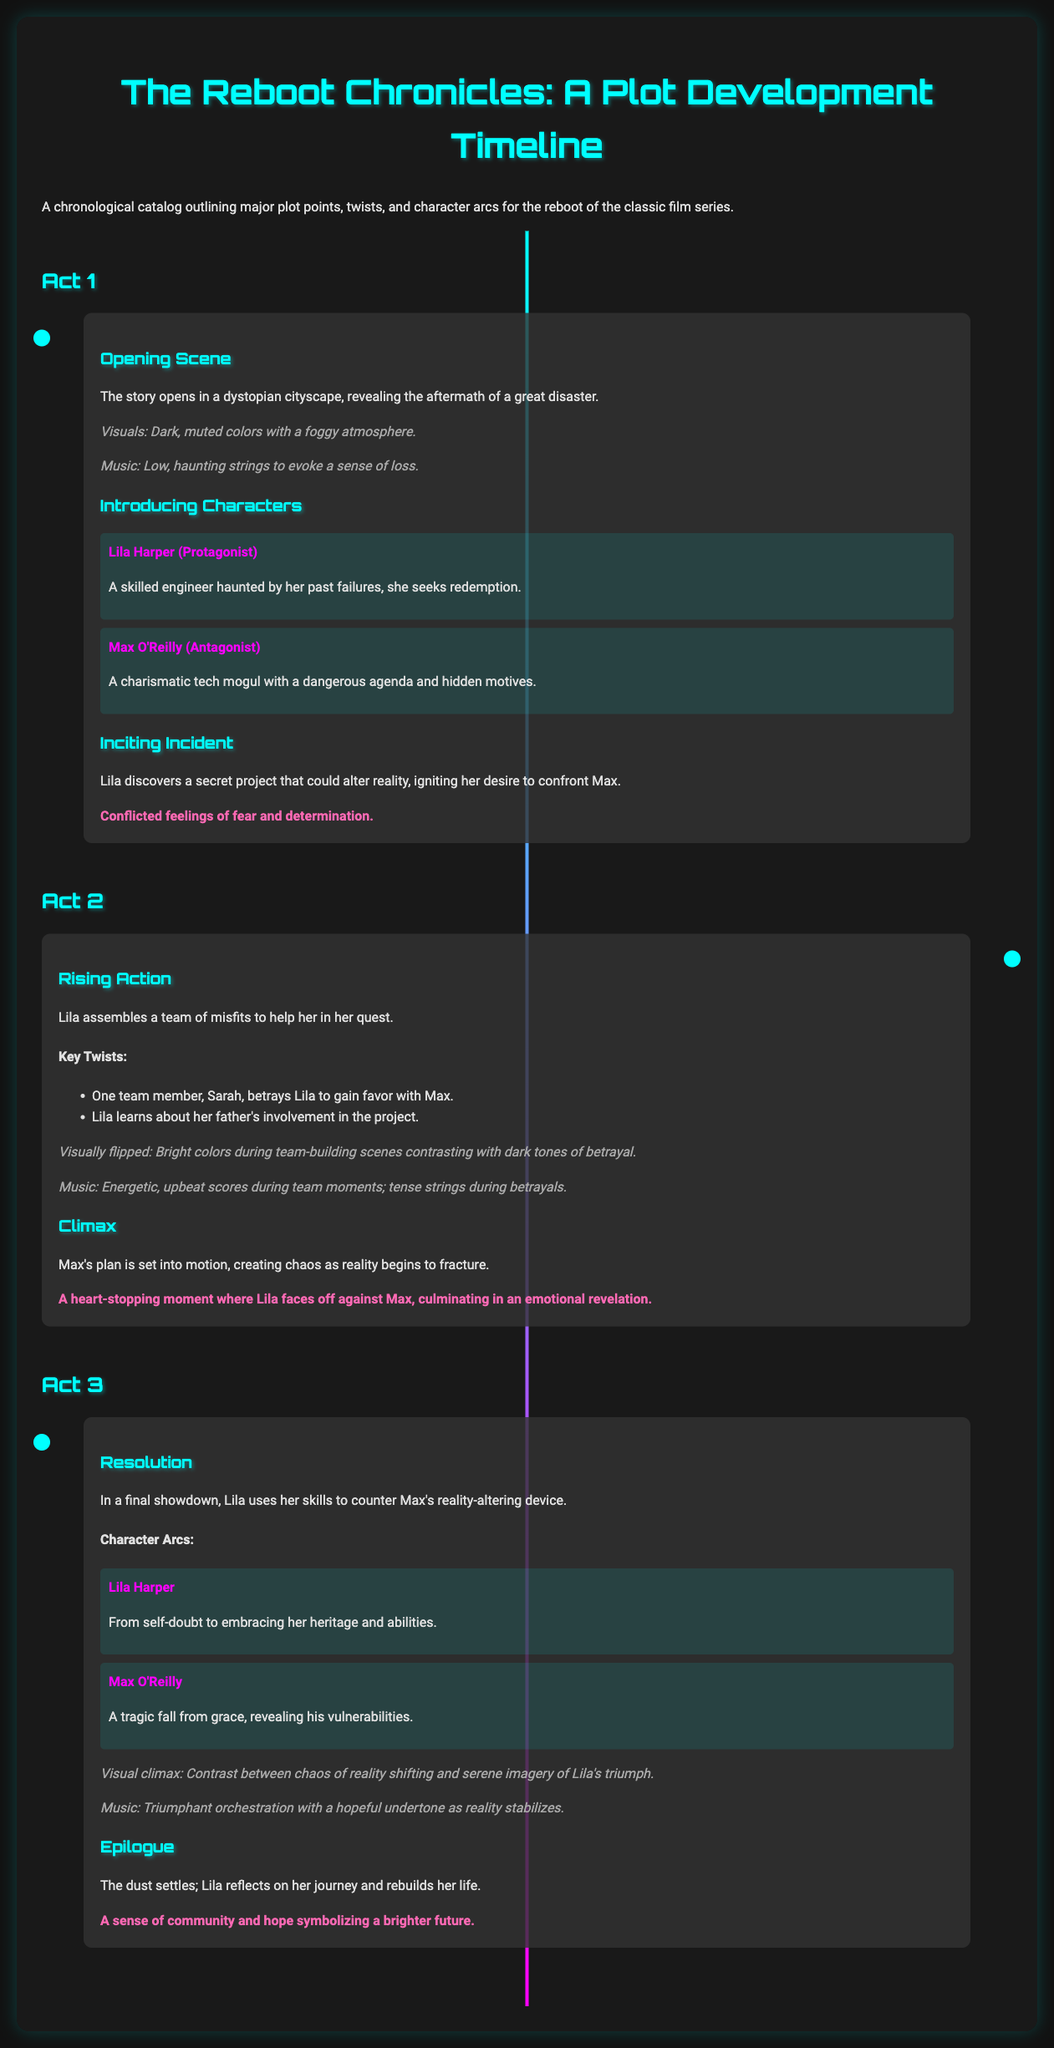What is the name of the protagonist? The protagonist is introduced in the document as Lila Harper, who seeks redemption.
Answer: Lila Harper Who is the antagonist? The document identifies the antagonist as Max O'Reilly, described as a charismatic tech mogul.
Answer: Max O'Reilly What significant event does the inciting incident revolve around? The inciting incident involves Lila discovering a secret project that could alter reality.
Answer: Secret project What emotional feeling does Lila experience during the inciting incident? The document mentions Lila's conflicted feelings of fear and determination at this pivotal moment.
Answer: Fear and determination How many key twists are mentioned in Act 2? Act 2 includes two key twists regarding team dynamics and background revelations.
Answer: Two What transformation does Lila undergo by the end of the story? Lila transforms from self-doubt to embracing her heritage and abilities, showcasing her growth.
Answer: Embracing her heritage What is the genre of the film as indicated by the setting? The dystopian cityscape described in the opening scene suggests a science fiction genre.
Answer: Science fiction Which music style is associated with the climax of the story? The document states that triumphant orchestration with a hopeful undertone is present during the story's climax.
Answer: Triumphant orchestration What does the final emotional beat signify in the epilogue? In the epilogue, the emotional beat signifies a sense of community and hope for a brighter future.
Answer: Sense of community and hope 